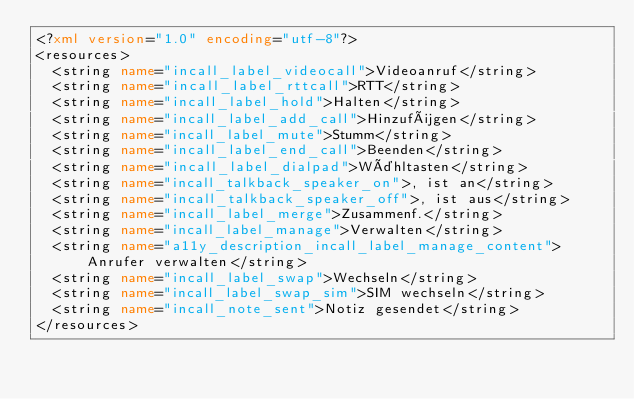<code> <loc_0><loc_0><loc_500><loc_500><_XML_><?xml version="1.0" encoding="utf-8"?>
<resources>
  <string name="incall_label_videocall">Videoanruf</string>
  <string name="incall_label_rttcall">RTT</string>
  <string name="incall_label_hold">Halten</string>
  <string name="incall_label_add_call">Hinzufügen</string>
  <string name="incall_label_mute">Stumm</string>
  <string name="incall_label_end_call">Beenden</string>
  <string name="incall_label_dialpad">Wähltasten</string>
  <string name="incall_talkback_speaker_on">, ist an</string>
  <string name="incall_talkback_speaker_off">, ist aus</string>
  <string name="incall_label_merge">Zusammenf.</string>
  <string name="incall_label_manage">Verwalten</string>
  <string name="a11y_description_incall_label_manage_content">Anrufer verwalten</string>
  <string name="incall_label_swap">Wechseln</string>
  <string name="incall_label_swap_sim">SIM wechseln</string>
  <string name="incall_note_sent">Notiz gesendet</string>
</resources>
</code> 